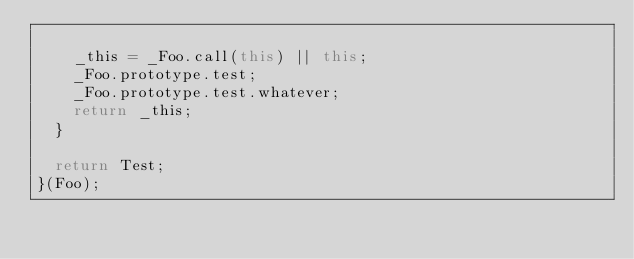Convert code to text. <code><loc_0><loc_0><loc_500><loc_500><_JavaScript_>
    _this = _Foo.call(this) || this;
    _Foo.prototype.test;
    _Foo.prototype.test.whatever;
    return _this;
  }

  return Test;
}(Foo);
</code> 